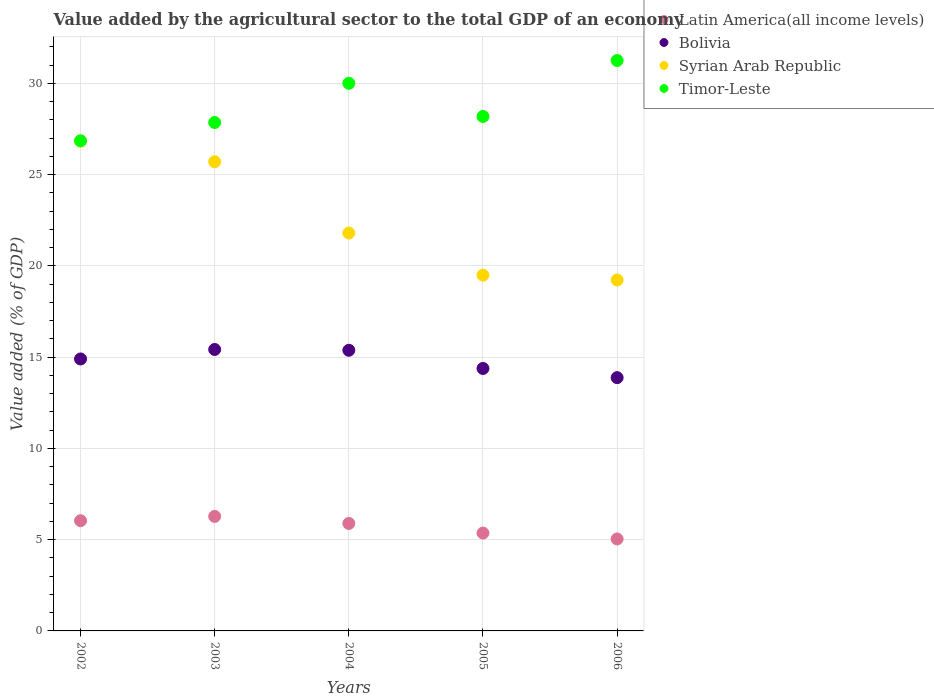What is the value added by the agricultural sector to the total GDP in Syrian Arab Republic in 2005?
Make the answer very short. 19.49. Across all years, what is the maximum value added by the agricultural sector to the total GDP in Bolivia?
Your answer should be compact. 15.42. Across all years, what is the minimum value added by the agricultural sector to the total GDP in Timor-Leste?
Your answer should be compact. 26.85. What is the total value added by the agricultural sector to the total GDP in Latin America(all income levels) in the graph?
Give a very brief answer. 28.6. What is the difference between the value added by the agricultural sector to the total GDP in Bolivia in 2003 and that in 2004?
Offer a very short reply. 0.04. What is the difference between the value added by the agricultural sector to the total GDP in Syrian Arab Republic in 2004 and the value added by the agricultural sector to the total GDP in Latin America(all income levels) in 2003?
Make the answer very short. 15.53. What is the average value added by the agricultural sector to the total GDP in Timor-Leste per year?
Your answer should be compact. 28.83. In the year 2003, what is the difference between the value added by the agricultural sector to the total GDP in Latin America(all income levels) and value added by the agricultural sector to the total GDP in Timor-Leste?
Keep it short and to the point. -21.58. What is the ratio of the value added by the agricultural sector to the total GDP in Timor-Leste in 2002 to that in 2006?
Offer a terse response. 0.86. Is the difference between the value added by the agricultural sector to the total GDP in Latin America(all income levels) in 2004 and 2006 greater than the difference between the value added by the agricultural sector to the total GDP in Timor-Leste in 2004 and 2006?
Give a very brief answer. Yes. What is the difference between the highest and the second highest value added by the agricultural sector to the total GDP in Bolivia?
Your answer should be compact. 0.04. What is the difference between the highest and the lowest value added by the agricultural sector to the total GDP in Timor-Leste?
Make the answer very short. 4.4. In how many years, is the value added by the agricultural sector to the total GDP in Syrian Arab Republic greater than the average value added by the agricultural sector to the total GDP in Syrian Arab Republic taken over all years?
Provide a succinct answer. 2. Is it the case that in every year, the sum of the value added by the agricultural sector to the total GDP in Timor-Leste and value added by the agricultural sector to the total GDP in Syrian Arab Republic  is greater than the sum of value added by the agricultural sector to the total GDP in Latin America(all income levels) and value added by the agricultural sector to the total GDP in Bolivia?
Provide a short and direct response. No. Is the value added by the agricultural sector to the total GDP in Latin America(all income levels) strictly greater than the value added by the agricultural sector to the total GDP in Timor-Leste over the years?
Provide a succinct answer. No. Is the value added by the agricultural sector to the total GDP in Latin America(all income levels) strictly less than the value added by the agricultural sector to the total GDP in Bolivia over the years?
Offer a very short reply. Yes. What is the difference between two consecutive major ticks on the Y-axis?
Your answer should be compact. 5. Does the graph contain any zero values?
Provide a succinct answer. No. Does the graph contain grids?
Your answer should be very brief. Yes. How many legend labels are there?
Offer a terse response. 4. What is the title of the graph?
Keep it short and to the point. Value added by the agricultural sector to the total GDP of an economy. Does "Myanmar" appear as one of the legend labels in the graph?
Offer a very short reply. No. What is the label or title of the X-axis?
Your response must be concise. Years. What is the label or title of the Y-axis?
Offer a terse response. Value added (% of GDP). What is the Value added (% of GDP) of Latin America(all income levels) in 2002?
Your answer should be compact. 6.04. What is the Value added (% of GDP) of Bolivia in 2002?
Offer a very short reply. 14.9. What is the Value added (% of GDP) in Syrian Arab Republic in 2002?
Give a very brief answer. 26.83. What is the Value added (% of GDP) in Timor-Leste in 2002?
Make the answer very short. 26.85. What is the Value added (% of GDP) of Latin America(all income levels) in 2003?
Ensure brevity in your answer.  6.27. What is the Value added (% of GDP) in Bolivia in 2003?
Keep it short and to the point. 15.42. What is the Value added (% of GDP) in Syrian Arab Republic in 2003?
Offer a very short reply. 25.7. What is the Value added (% of GDP) in Timor-Leste in 2003?
Offer a very short reply. 27.85. What is the Value added (% of GDP) of Latin America(all income levels) in 2004?
Provide a succinct answer. 5.89. What is the Value added (% of GDP) of Bolivia in 2004?
Keep it short and to the point. 15.37. What is the Value added (% of GDP) in Syrian Arab Republic in 2004?
Offer a very short reply. 21.8. What is the Value added (% of GDP) of Timor-Leste in 2004?
Give a very brief answer. 30. What is the Value added (% of GDP) of Latin America(all income levels) in 2005?
Ensure brevity in your answer.  5.36. What is the Value added (% of GDP) of Bolivia in 2005?
Offer a very short reply. 14.38. What is the Value added (% of GDP) of Syrian Arab Republic in 2005?
Your response must be concise. 19.49. What is the Value added (% of GDP) of Timor-Leste in 2005?
Your answer should be compact. 28.18. What is the Value added (% of GDP) in Latin America(all income levels) in 2006?
Provide a succinct answer. 5.04. What is the Value added (% of GDP) of Bolivia in 2006?
Your answer should be compact. 13.88. What is the Value added (% of GDP) in Syrian Arab Republic in 2006?
Keep it short and to the point. 19.22. What is the Value added (% of GDP) of Timor-Leste in 2006?
Make the answer very short. 31.25. Across all years, what is the maximum Value added (% of GDP) of Latin America(all income levels)?
Your response must be concise. 6.27. Across all years, what is the maximum Value added (% of GDP) in Bolivia?
Offer a terse response. 15.42. Across all years, what is the maximum Value added (% of GDP) in Syrian Arab Republic?
Provide a succinct answer. 26.83. Across all years, what is the maximum Value added (% of GDP) of Timor-Leste?
Your answer should be very brief. 31.25. Across all years, what is the minimum Value added (% of GDP) of Latin America(all income levels)?
Offer a terse response. 5.04. Across all years, what is the minimum Value added (% of GDP) of Bolivia?
Offer a very short reply. 13.88. Across all years, what is the minimum Value added (% of GDP) of Syrian Arab Republic?
Your response must be concise. 19.22. Across all years, what is the minimum Value added (% of GDP) in Timor-Leste?
Provide a succinct answer. 26.85. What is the total Value added (% of GDP) of Latin America(all income levels) in the graph?
Keep it short and to the point. 28.6. What is the total Value added (% of GDP) in Bolivia in the graph?
Your response must be concise. 73.95. What is the total Value added (% of GDP) of Syrian Arab Republic in the graph?
Offer a terse response. 113.05. What is the total Value added (% of GDP) in Timor-Leste in the graph?
Give a very brief answer. 144.14. What is the difference between the Value added (% of GDP) in Latin America(all income levels) in 2002 and that in 2003?
Make the answer very short. -0.23. What is the difference between the Value added (% of GDP) in Bolivia in 2002 and that in 2003?
Your answer should be compact. -0.52. What is the difference between the Value added (% of GDP) in Syrian Arab Republic in 2002 and that in 2003?
Give a very brief answer. 1.13. What is the difference between the Value added (% of GDP) of Timor-Leste in 2002 and that in 2003?
Give a very brief answer. -1. What is the difference between the Value added (% of GDP) of Latin America(all income levels) in 2002 and that in 2004?
Offer a very short reply. 0.15. What is the difference between the Value added (% of GDP) of Bolivia in 2002 and that in 2004?
Your answer should be compact. -0.48. What is the difference between the Value added (% of GDP) of Syrian Arab Republic in 2002 and that in 2004?
Provide a short and direct response. 5.03. What is the difference between the Value added (% of GDP) of Timor-Leste in 2002 and that in 2004?
Ensure brevity in your answer.  -3.15. What is the difference between the Value added (% of GDP) of Latin America(all income levels) in 2002 and that in 2005?
Your response must be concise. 0.68. What is the difference between the Value added (% of GDP) in Bolivia in 2002 and that in 2005?
Provide a succinct answer. 0.52. What is the difference between the Value added (% of GDP) of Syrian Arab Republic in 2002 and that in 2005?
Make the answer very short. 7.34. What is the difference between the Value added (% of GDP) of Timor-Leste in 2002 and that in 2005?
Offer a terse response. -1.33. What is the difference between the Value added (% of GDP) in Bolivia in 2002 and that in 2006?
Your response must be concise. 1.02. What is the difference between the Value added (% of GDP) of Syrian Arab Republic in 2002 and that in 2006?
Provide a succinct answer. 7.61. What is the difference between the Value added (% of GDP) in Timor-Leste in 2002 and that in 2006?
Your response must be concise. -4.4. What is the difference between the Value added (% of GDP) of Latin America(all income levels) in 2003 and that in 2004?
Make the answer very short. 0.38. What is the difference between the Value added (% of GDP) of Bolivia in 2003 and that in 2004?
Your answer should be compact. 0.04. What is the difference between the Value added (% of GDP) in Syrian Arab Republic in 2003 and that in 2004?
Your answer should be compact. 3.9. What is the difference between the Value added (% of GDP) in Timor-Leste in 2003 and that in 2004?
Your response must be concise. -2.15. What is the difference between the Value added (% of GDP) of Latin America(all income levels) in 2003 and that in 2005?
Give a very brief answer. 0.91. What is the difference between the Value added (% of GDP) in Syrian Arab Republic in 2003 and that in 2005?
Make the answer very short. 6.21. What is the difference between the Value added (% of GDP) of Timor-Leste in 2003 and that in 2005?
Provide a succinct answer. -0.33. What is the difference between the Value added (% of GDP) in Latin America(all income levels) in 2003 and that in 2006?
Your response must be concise. 1.23. What is the difference between the Value added (% of GDP) in Bolivia in 2003 and that in 2006?
Offer a very short reply. 1.54. What is the difference between the Value added (% of GDP) in Syrian Arab Republic in 2003 and that in 2006?
Make the answer very short. 6.48. What is the difference between the Value added (% of GDP) of Timor-Leste in 2003 and that in 2006?
Provide a succinct answer. -3.4. What is the difference between the Value added (% of GDP) of Latin America(all income levels) in 2004 and that in 2005?
Offer a terse response. 0.53. What is the difference between the Value added (% of GDP) in Syrian Arab Republic in 2004 and that in 2005?
Provide a short and direct response. 2.31. What is the difference between the Value added (% of GDP) of Timor-Leste in 2004 and that in 2005?
Make the answer very short. 1.82. What is the difference between the Value added (% of GDP) in Latin America(all income levels) in 2004 and that in 2006?
Provide a short and direct response. 0.85. What is the difference between the Value added (% of GDP) in Bolivia in 2004 and that in 2006?
Offer a terse response. 1.5. What is the difference between the Value added (% of GDP) in Syrian Arab Republic in 2004 and that in 2006?
Provide a short and direct response. 2.57. What is the difference between the Value added (% of GDP) in Timor-Leste in 2004 and that in 2006?
Keep it short and to the point. -1.25. What is the difference between the Value added (% of GDP) of Latin America(all income levels) in 2005 and that in 2006?
Ensure brevity in your answer.  0.32. What is the difference between the Value added (% of GDP) in Bolivia in 2005 and that in 2006?
Provide a short and direct response. 0.5. What is the difference between the Value added (% of GDP) in Syrian Arab Republic in 2005 and that in 2006?
Give a very brief answer. 0.26. What is the difference between the Value added (% of GDP) of Timor-Leste in 2005 and that in 2006?
Offer a terse response. -3.07. What is the difference between the Value added (% of GDP) in Latin America(all income levels) in 2002 and the Value added (% of GDP) in Bolivia in 2003?
Provide a succinct answer. -9.38. What is the difference between the Value added (% of GDP) in Latin America(all income levels) in 2002 and the Value added (% of GDP) in Syrian Arab Republic in 2003?
Give a very brief answer. -19.66. What is the difference between the Value added (% of GDP) in Latin America(all income levels) in 2002 and the Value added (% of GDP) in Timor-Leste in 2003?
Provide a succinct answer. -21.82. What is the difference between the Value added (% of GDP) of Bolivia in 2002 and the Value added (% of GDP) of Syrian Arab Republic in 2003?
Your answer should be very brief. -10.8. What is the difference between the Value added (% of GDP) of Bolivia in 2002 and the Value added (% of GDP) of Timor-Leste in 2003?
Make the answer very short. -12.96. What is the difference between the Value added (% of GDP) of Syrian Arab Republic in 2002 and the Value added (% of GDP) of Timor-Leste in 2003?
Offer a very short reply. -1.02. What is the difference between the Value added (% of GDP) in Latin America(all income levels) in 2002 and the Value added (% of GDP) in Bolivia in 2004?
Your response must be concise. -9.34. What is the difference between the Value added (% of GDP) in Latin America(all income levels) in 2002 and the Value added (% of GDP) in Syrian Arab Republic in 2004?
Keep it short and to the point. -15.76. What is the difference between the Value added (% of GDP) in Latin America(all income levels) in 2002 and the Value added (% of GDP) in Timor-Leste in 2004?
Keep it short and to the point. -23.96. What is the difference between the Value added (% of GDP) of Bolivia in 2002 and the Value added (% of GDP) of Syrian Arab Republic in 2004?
Provide a short and direct response. -6.9. What is the difference between the Value added (% of GDP) of Bolivia in 2002 and the Value added (% of GDP) of Timor-Leste in 2004?
Offer a very short reply. -15.1. What is the difference between the Value added (% of GDP) in Syrian Arab Republic in 2002 and the Value added (% of GDP) in Timor-Leste in 2004?
Your answer should be compact. -3.17. What is the difference between the Value added (% of GDP) of Latin America(all income levels) in 2002 and the Value added (% of GDP) of Bolivia in 2005?
Your answer should be very brief. -8.34. What is the difference between the Value added (% of GDP) of Latin America(all income levels) in 2002 and the Value added (% of GDP) of Syrian Arab Republic in 2005?
Ensure brevity in your answer.  -13.45. What is the difference between the Value added (% of GDP) of Latin America(all income levels) in 2002 and the Value added (% of GDP) of Timor-Leste in 2005?
Provide a short and direct response. -22.15. What is the difference between the Value added (% of GDP) in Bolivia in 2002 and the Value added (% of GDP) in Syrian Arab Republic in 2005?
Your answer should be compact. -4.59. What is the difference between the Value added (% of GDP) in Bolivia in 2002 and the Value added (% of GDP) in Timor-Leste in 2005?
Your answer should be very brief. -13.28. What is the difference between the Value added (% of GDP) of Syrian Arab Republic in 2002 and the Value added (% of GDP) of Timor-Leste in 2005?
Ensure brevity in your answer.  -1.35. What is the difference between the Value added (% of GDP) of Latin America(all income levels) in 2002 and the Value added (% of GDP) of Bolivia in 2006?
Offer a terse response. -7.84. What is the difference between the Value added (% of GDP) of Latin America(all income levels) in 2002 and the Value added (% of GDP) of Syrian Arab Republic in 2006?
Your answer should be compact. -13.19. What is the difference between the Value added (% of GDP) of Latin America(all income levels) in 2002 and the Value added (% of GDP) of Timor-Leste in 2006?
Keep it short and to the point. -25.21. What is the difference between the Value added (% of GDP) of Bolivia in 2002 and the Value added (% of GDP) of Syrian Arab Republic in 2006?
Your answer should be very brief. -4.33. What is the difference between the Value added (% of GDP) in Bolivia in 2002 and the Value added (% of GDP) in Timor-Leste in 2006?
Your answer should be very brief. -16.35. What is the difference between the Value added (% of GDP) of Syrian Arab Republic in 2002 and the Value added (% of GDP) of Timor-Leste in 2006?
Offer a terse response. -4.42. What is the difference between the Value added (% of GDP) of Latin America(all income levels) in 2003 and the Value added (% of GDP) of Bolivia in 2004?
Make the answer very short. -9.1. What is the difference between the Value added (% of GDP) of Latin America(all income levels) in 2003 and the Value added (% of GDP) of Syrian Arab Republic in 2004?
Your answer should be compact. -15.53. What is the difference between the Value added (% of GDP) of Latin America(all income levels) in 2003 and the Value added (% of GDP) of Timor-Leste in 2004?
Offer a very short reply. -23.73. What is the difference between the Value added (% of GDP) of Bolivia in 2003 and the Value added (% of GDP) of Syrian Arab Republic in 2004?
Ensure brevity in your answer.  -6.38. What is the difference between the Value added (% of GDP) in Bolivia in 2003 and the Value added (% of GDP) in Timor-Leste in 2004?
Your answer should be very brief. -14.58. What is the difference between the Value added (% of GDP) in Syrian Arab Republic in 2003 and the Value added (% of GDP) in Timor-Leste in 2004?
Your response must be concise. -4.3. What is the difference between the Value added (% of GDP) in Latin America(all income levels) in 2003 and the Value added (% of GDP) in Bolivia in 2005?
Keep it short and to the point. -8.11. What is the difference between the Value added (% of GDP) of Latin America(all income levels) in 2003 and the Value added (% of GDP) of Syrian Arab Republic in 2005?
Make the answer very short. -13.22. What is the difference between the Value added (% of GDP) of Latin America(all income levels) in 2003 and the Value added (% of GDP) of Timor-Leste in 2005?
Your response must be concise. -21.91. What is the difference between the Value added (% of GDP) in Bolivia in 2003 and the Value added (% of GDP) in Syrian Arab Republic in 2005?
Provide a short and direct response. -4.07. What is the difference between the Value added (% of GDP) of Bolivia in 2003 and the Value added (% of GDP) of Timor-Leste in 2005?
Your response must be concise. -12.77. What is the difference between the Value added (% of GDP) in Syrian Arab Republic in 2003 and the Value added (% of GDP) in Timor-Leste in 2005?
Make the answer very short. -2.48. What is the difference between the Value added (% of GDP) of Latin America(all income levels) in 2003 and the Value added (% of GDP) of Bolivia in 2006?
Your response must be concise. -7.6. What is the difference between the Value added (% of GDP) in Latin America(all income levels) in 2003 and the Value added (% of GDP) in Syrian Arab Republic in 2006?
Offer a very short reply. -12.95. What is the difference between the Value added (% of GDP) in Latin America(all income levels) in 2003 and the Value added (% of GDP) in Timor-Leste in 2006?
Keep it short and to the point. -24.98. What is the difference between the Value added (% of GDP) in Bolivia in 2003 and the Value added (% of GDP) in Syrian Arab Republic in 2006?
Give a very brief answer. -3.81. What is the difference between the Value added (% of GDP) in Bolivia in 2003 and the Value added (% of GDP) in Timor-Leste in 2006?
Provide a short and direct response. -15.83. What is the difference between the Value added (% of GDP) of Syrian Arab Republic in 2003 and the Value added (% of GDP) of Timor-Leste in 2006?
Provide a succinct answer. -5.55. What is the difference between the Value added (% of GDP) in Latin America(all income levels) in 2004 and the Value added (% of GDP) in Bolivia in 2005?
Keep it short and to the point. -8.49. What is the difference between the Value added (% of GDP) in Latin America(all income levels) in 2004 and the Value added (% of GDP) in Syrian Arab Republic in 2005?
Your response must be concise. -13.6. What is the difference between the Value added (% of GDP) of Latin America(all income levels) in 2004 and the Value added (% of GDP) of Timor-Leste in 2005?
Your answer should be compact. -22.29. What is the difference between the Value added (% of GDP) in Bolivia in 2004 and the Value added (% of GDP) in Syrian Arab Republic in 2005?
Keep it short and to the point. -4.12. What is the difference between the Value added (% of GDP) in Bolivia in 2004 and the Value added (% of GDP) in Timor-Leste in 2005?
Your response must be concise. -12.81. What is the difference between the Value added (% of GDP) of Syrian Arab Republic in 2004 and the Value added (% of GDP) of Timor-Leste in 2005?
Provide a short and direct response. -6.38. What is the difference between the Value added (% of GDP) of Latin America(all income levels) in 2004 and the Value added (% of GDP) of Bolivia in 2006?
Your response must be concise. -7.99. What is the difference between the Value added (% of GDP) in Latin America(all income levels) in 2004 and the Value added (% of GDP) in Syrian Arab Republic in 2006?
Ensure brevity in your answer.  -13.34. What is the difference between the Value added (% of GDP) in Latin America(all income levels) in 2004 and the Value added (% of GDP) in Timor-Leste in 2006?
Provide a succinct answer. -25.36. What is the difference between the Value added (% of GDP) in Bolivia in 2004 and the Value added (% of GDP) in Syrian Arab Republic in 2006?
Ensure brevity in your answer.  -3.85. What is the difference between the Value added (% of GDP) of Bolivia in 2004 and the Value added (% of GDP) of Timor-Leste in 2006?
Keep it short and to the point. -15.88. What is the difference between the Value added (% of GDP) of Syrian Arab Republic in 2004 and the Value added (% of GDP) of Timor-Leste in 2006?
Ensure brevity in your answer.  -9.45. What is the difference between the Value added (% of GDP) in Latin America(all income levels) in 2005 and the Value added (% of GDP) in Bolivia in 2006?
Keep it short and to the point. -8.52. What is the difference between the Value added (% of GDP) of Latin America(all income levels) in 2005 and the Value added (% of GDP) of Syrian Arab Republic in 2006?
Ensure brevity in your answer.  -13.86. What is the difference between the Value added (% of GDP) of Latin America(all income levels) in 2005 and the Value added (% of GDP) of Timor-Leste in 2006?
Offer a very short reply. -25.89. What is the difference between the Value added (% of GDP) in Bolivia in 2005 and the Value added (% of GDP) in Syrian Arab Republic in 2006?
Ensure brevity in your answer.  -4.85. What is the difference between the Value added (% of GDP) in Bolivia in 2005 and the Value added (% of GDP) in Timor-Leste in 2006?
Keep it short and to the point. -16.87. What is the difference between the Value added (% of GDP) of Syrian Arab Republic in 2005 and the Value added (% of GDP) of Timor-Leste in 2006?
Your answer should be compact. -11.76. What is the average Value added (% of GDP) in Latin America(all income levels) per year?
Your response must be concise. 5.72. What is the average Value added (% of GDP) of Bolivia per year?
Give a very brief answer. 14.79. What is the average Value added (% of GDP) of Syrian Arab Republic per year?
Offer a terse response. 22.61. What is the average Value added (% of GDP) in Timor-Leste per year?
Your answer should be very brief. 28.83. In the year 2002, what is the difference between the Value added (% of GDP) of Latin America(all income levels) and Value added (% of GDP) of Bolivia?
Give a very brief answer. -8.86. In the year 2002, what is the difference between the Value added (% of GDP) in Latin America(all income levels) and Value added (% of GDP) in Syrian Arab Republic?
Your answer should be compact. -20.79. In the year 2002, what is the difference between the Value added (% of GDP) of Latin America(all income levels) and Value added (% of GDP) of Timor-Leste?
Give a very brief answer. -20.81. In the year 2002, what is the difference between the Value added (% of GDP) of Bolivia and Value added (% of GDP) of Syrian Arab Republic?
Offer a terse response. -11.93. In the year 2002, what is the difference between the Value added (% of GDP) in Bolivia and Value added (% of GDP) in Timor-Leste?
Provide a short and direct response. -11.95. In the year 2002, what is the difference between the Value added (% of GDP) of Syrian Arab Republic and Value added (% of GDP) of Timor-Leste?
Make the answer very short. -0.02. In the year 2003, what is the difference between the Value added (% of GDP) of Latin America(all income levels) and Value added (% of GDP) of Bolivia?
Ensure brevity in your answer.  -9.15. In the year 2003, what is the difference between the Value added (% of GDP) in Latin America(all income levels) and Value added (% of GDP) in Syrian Arab Republic?
Your response must be concise. -19.43. In the year 2003, what is the difference between the Value added (% of GDP) in Latin America(all income levels) and Value added (% of GDP) in Timor-Leste?
Make the answer very short. -21.58. In the year 2003, what is the difference between the Value added (% of GDP) of Bolivia and Value added (% of GDP) of Syrian Arab Republic?
Keep it short and to the point. -10.28. In the year 2003, what is the difference between the Value added (% of GDP) of Bolivia and Value added (% of GDP) of Timor-Leste?
Your answer should be very brief. -12.44. In the year 2003, what is the difference between the Value added (% of GDP) of Syrian Arab Republic and Value added (% of GDP) of Timor-Leste?
Your response must be concise. -2.15. In the year 2004, what is the difference between the Value added (% of GDP) of Latin America(all income levels) and Value added (% of GDP) of Bolivia?
Ensure brevity in your answer.  -9.49. In the year 2004, what is the difference between the Value added (% of GDP) of Latin America(all income levels) and Value added (% of GDP) of Syrian Arab Republic?
Offer a terse response. -15.91. In the year 2004, what is the difference between the Value added (% of GDP) in Latin America(all income levels) and Value added (% of GDP) in Timor-Leste?
Offer a terse response. -24.11. In the year 2004, what is the difference between the Value added (% of GDP) in Bolivia and Value added (% of GDP) in Syrian Arab Republic?
Provide a succinct answer. -6.42. In the year 2004, what is the difference between the Value added (% of GDP) of Bolivia and Value added (% of GDP) of Timor-Leste?
Your answer should be very brief. -14.63. In the year 2004, what is the difference between the Value added (% of GDP) in Syrian Arab Republic and Value added (% of GDP) in Timor-Leste?
Your response must be concise. -8.2. In the year 2005, what is the difference between the Value added (% of GDP) in Latin America(all income levels) and Value added (% of GDP) in Bolivia?
Make the answer very short. -9.02. In the year 2005, what is the difference between the Value added (% of GDP) of Latin America(all income levels) and Value added (% of GDP) of Syrian Arab Republic?
Your response must be concise. -14.13. In the year 2005, what is the difference between the Value added (% of GDP) of Latin America(all income levels) and Value added (% of GDP) of Timor-Leste?
Offer a very short reply. -22.82. In the year 2005, what is the difference between the Value added (% of GDP) of Bolivia and Value added (% of GDP) of Syrian Arab Republic?
Offer a terse response. -5.11. In the year 2005, what is the difference between the Value added (% of GDP) of Bolivia and Value added (% of GDP) of Timor-Leste?
Keep it short and to the point. -13.81. In the year 2005, what is the difference between the Value added (% of GDP) of Syrian Arab Republic and Value added (% of GDP) of Timor-Leste?
Your answer should be very brief. -8.69. In the year 2006, what is the difference between the Value added (% of GDP) of Latin America(all income levels) and Value added (% of GDP) of Bolivia?
Your answer should be very brief. -8.84. In the year 2006, what is the difference between the Value added (% of GDP) of Latin America(all income levels) and Value added (% of GDP) of Syrian Arab Republic?
Give a very brief answer. -14.19. In the year 2006, what is the difference between the Value added (% of GDP) in Latin America(all income levels) and Value added (% of GDP) in Timor-Leste?
Provide a succinct answer. -26.21. In the year 2006, what is the difference between the Value added (% of GDP) in Bolivia and Value added (% of GDP) in Syrian Arab Republic?
Your response must be concise. -5.35. In the year 2006, what is the difference between the Value added (% of GDP) of Bolivia and Value added (% of GDP) of Timor-Leste?
Your response must be concise. -17.37. In the year 2006, what is the difference between the Value added (% of GDP) of Syrian Arab Republic and Value added (% of GDP) of Timor-Leste?
Make the answer very short. -12.03. What is the ratio of the Value added (% of GDP) of Latin America(all income levels) in 2002 to that in 2003?
Ensure brevity in your answer.  0.96. What is the ratio of the Value added (% of GDP) of Bolivia in 2002 to that in 2003?
Make the answer very short. 0.97. What is the ratio of the Value added (% of GDP) in Syrian Arab Republic in 2002 to that in 2003?
Your answer should be compact. 1.04. What is the ratio of the Value added (% of GDP) of Timor-Leste in 2002 to that in 2003?
Your response must be concise. 0.96. What is the ratio of the Value added (% of GDP) of Latin America(all income levels) in 2002 to that in 2004?
Keep it short and to the point. 1.03. What is the ratio of the Value added (% of GDP) of Syrian Arab Republic in 2002 to that in 2004?
Offer a very short reply. 1.23. What is the ratio of the Value added (% of GDP) in Timor-Leste in 2002 to that in 2004?
Keep it short and to the point. 0.9. What is the ratio of the Value added (% of GDP) in Latin America(all income levels) in 2002 to that in 2005?
Your answer should be compact. 1.13. What is the ratio of the Value added (% of GDP) of Bolivia in 2002 to that in 2005?
Your answer should be compact. 1.04. What is the ratio of the Value added (% of GDP) of Syrian Arab Republic in 2002 to that in 2005?
Provide a short and direct response. 1.38. What is the ratio of the Value added (% of GDP) in Timor-Leste in 2002 to that in 2005?
Ensure brevity in your answer.  0.95. What is the ratio of the Value added (% of GDP) of Latin America(all income levels) in 2002 to that in 2006?
Provide a short and direct response. 1.2. What is the ratio of the Value added (% of GDP) in Bolivia in 2002 to that in 2006?
Offer a very short reply. 1.07. What is the ratio of the Value added (% of GDP) in Syrian Arab Republic in 2002 to that in 2006?
Make the answer very short. 1.4. What is the ratio of the Value added (% of GDP) in Timor-Leste in 2002 to that in 2006?
Give a very brief answer. 0.86. What is the ratio of the Value added (% of GDP) of Latin America(all income levels) in 2003 to that in 2004?
Your answer should be compact. 1.07. What is the ratio of the Value added (% of GDP) of Syrian Arab Republic in 2003 to that in 2004?
Provide a short and direct response. 1.18. What is the ratio of the Value added (% of GDP) of Timor-Leste in 2003 to that in 2004?
Give a very brief answer. 0.93. What is the ratio of the Value added (% of GDP) of Latin America(all income levels) in 2003 to that in 2005?
Your response must be concise. 1.17. What is the ratio of the Value added (% of GDP) of Bolivia in 2003 to that in 2005?
Keep it short and to the point. 1.07. What is the ratio of the Value added (% of GDP) in Syrian Arab Republic in 2003 to that in 2005?
Your answer should be very brief. 1.32. What is the ratio of the Value added (% of GDP) of Timor-Leste in 2003 to that in 2005?
Make the answer very short. 0.99. What is the ratio of the Value added (% of GDP) in Latin America(all income levels) in 2003 to that in 2006?
Your answer should be very brief. 1.25. What is the ratio of the Value added (% of GDP) in Syrian Arab Republic in 2003 to that in 2006?
Offer a terse response. 1.34. What is the ratio of the Value added (% of GDP) of Timor-Leste in 2003 to that in 2006?
Make the answer very short. 0.89. What is the ratio of the Value added (% of GDP) of Latin America(all income levels) in 2004 to that in 2005?
Provide a succinct answer. 1.1. What is the ratio of the Value added (% of GDP) of Bolivia in 2004 to that in 2005?
Keep it short and to the point. 1.07. What is the ratio of the Value added (% of GDP) of Syrian Arab Republic in 2004 to that in 2005?
Offer a very short reply. 1.12. What is the ratio of the Value added (% of GDP) of Timor-Leste in 2004 to that in 2005?
Provide a succinct answer. 1.06. What is the ratio of the Value added (% of GDP) of Latin America(all income levels) in 2004 to that in 2006?
Ensure brevity in your answer.  1.17. What is the ratio of the Value added (% of GDP) in Bolivia in 2004 to that in 2006?
Provide a succinct answer. 1.11. What is the ratio of the Value added (% of GDP) in Syrian Arab Republic in 2004 to that in 2006?
Make the answer very short. 1.13. What is the ratio of the Value added (% of GDP) of Latin America(all income levels) in 2005 to that in 2006?
Offer a terse response. 1.06. What is the ratio of the Value added (% of GDP) in Bolivia in 2005 to that in 2006?
Your response must be concise. 1.04. What is the ratio of the Value added (% of GDP) in Syrian Arab Republic in 2005 to that in 2006?
Make the answer very short. 1.01. What is the ratio of the Value added (% of GDP) in Timor-Leste in 2005 to that in 2006?
Make the answer very short. 0.9. What is the difference between the highest and the second highest Value added (% of GDP) of Latin America(all income levels)?
Offer a terse response. 0.23. What is the difference between the highest and the second highest Value added (% of GDP) in Bolivia?
Keep it short and to the point. 0.04. What is the difference between the highest and the second highest Value added (% of GDP) in Syrian Arab Republic?
Keep it short and to the point. 1.13. What is the difference between the highest and the lowest Value added (% of GDP) in Latin America(all income levels)?
Offer a very short reply. 1.23. What is the difference between the highest and the lowest Value added (% of GDP) in Bolivia?
Provide a succinct answer. 1.54. What is the difference between the highest and the lowest Value added (% of GDP) in Syrian Arab Republic?
Keep it short and to the point. 7.61. What is the difference between the highest and the lowest Value added (% of GDP) of Timor-Leste?
Keep it short and to the point. 4.4. 